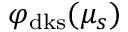Convert formula to latex. <formula><loc_0><loc_0><loc_500><loc_500>\varphi _ { d k s } ( \mu _ { s } )</formula> 